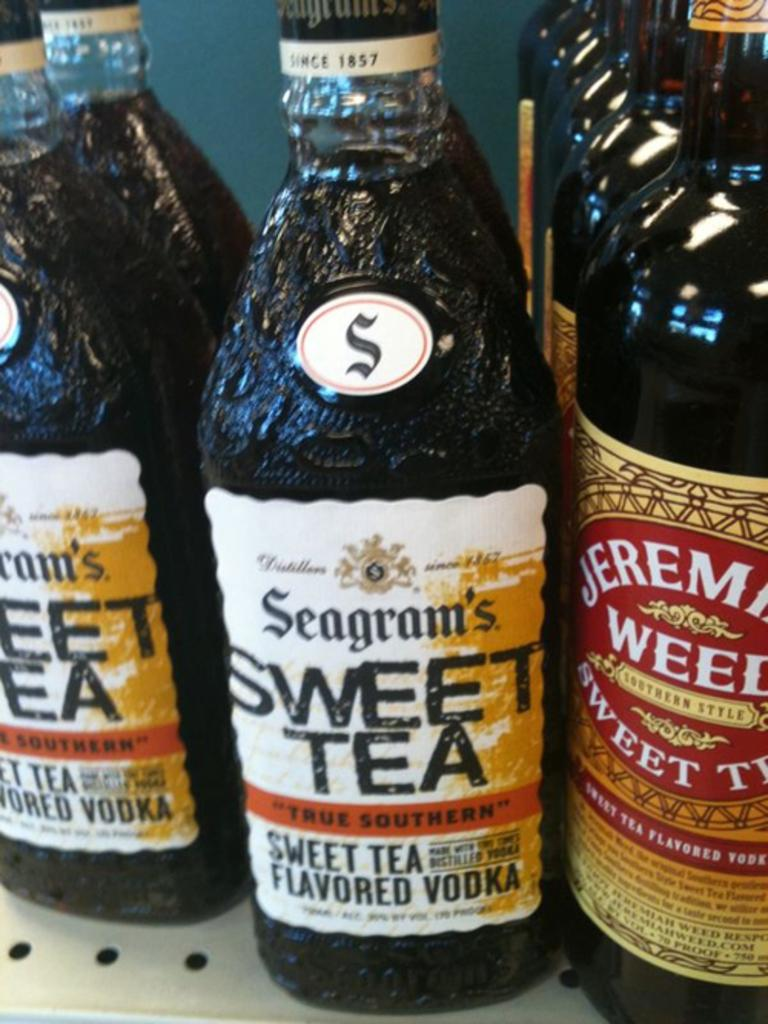<image>
Offer a succinct explanation of the picture presented. A close up of several bottles bearing the label sweet tea. 